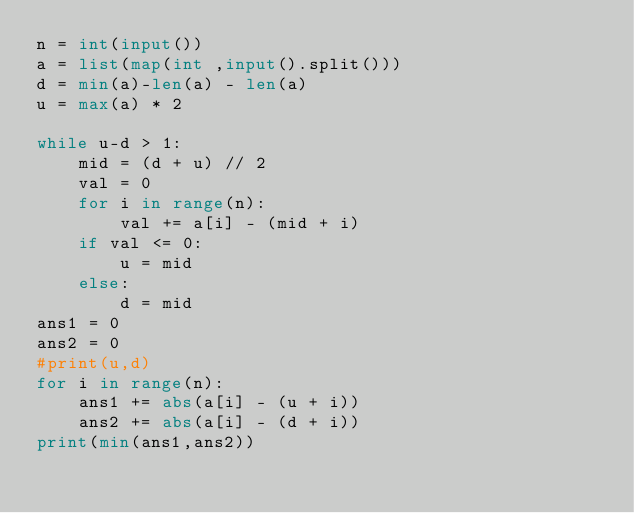<code> <loc_0><loc_0><loc_500><loc_500><_Python_>n = int(input())
a = list(map(int ,input().split()))
d = min(a)-len(a) - len(a)
u = max(a) * 2

while u-d > 1:
    mid = (d + u) // 2
    val = 0
    for i in range(n):
        val += a[i] - (mid + i)
    if val <= 0:
        u = mid
    else:
        d = mid
ans1 = 0
ans2 = 0
#print(u,d)
for i in range(n):
    ans1 += abs(a[i] - (u + i))
    ans2 += abs(a[i] - (d + i))
print(min(ans1,ans2))
</code> 